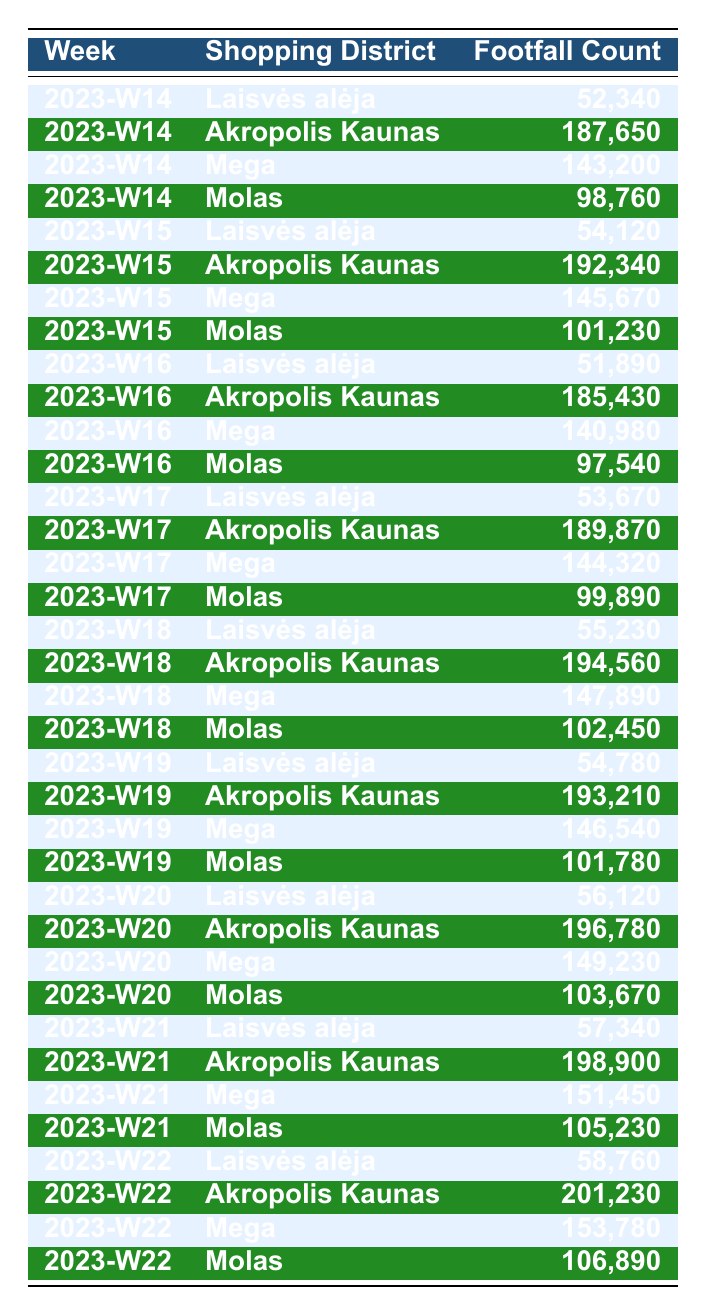What is the footfall count for Akropolis Kaunas in week 2023-W20? In the table under the "Akropolis Kaunas" row for the week "2023-W20," the footfall count is listed as 196,780.
Answer: 196,780 Which shopping district had the highest footfall in week 2023-W18? The table indicates that the footfall count for Akropolis Kaunas in week 2023-W18 is 194,560, which is higher than the other districts' counts listed for that week.
Answer: Akropolis Kaunas What was the average footfall count for Laisvės alėja over the six weeks? To find the average for Laisvės alėja, we sum the footfall counts over the six weeks: (52,340 + 54,120 + 51,890 + 53,670 + 55,230 + 57,340) = 324,590. Then, we divide by 6, giving us an average of 54,098.33.
Answer: 54,098 Did footfall in the Mega district increase every week? By examining the footfall counts for Mega across the weeks, we see that it does not increase every week. For example, it was 143,200 in week 2023-W14 but decreased to 140,980 in week 2023-W16.
Answer: No Which district had the most stable footfall count over the weeks? To determine stability, we look at the variance in footfall counts for each district. Comparing them, Laisvės alėja has the smallest range (54,120 to 58,760), suggesting it had the most stable footfall.
Answer: Laisvės alėja What is the total footfall count for all districts combined in week 2023-W15? We sum the footfall counts from all districts for 2023-W15: (54,120 + 192,340 + 145,670 + 101,230) = 493,360.
Answer: 493,360 Was there an increase in footfall count for Molas from week 2023-W14 to week 2023-W22? Comparing the footfall counts, Molas had 98,760 in week 2023-W14 and 106,890 in week 2023-W22, showing an increase.
Answer: Yes How much more footfall did Akropolis Kaunas receive than Mega in the week with the highest difference? In week 2023-W22, Akropolis Kaunas had a count of 201,230 and Mega had 153,780. The difference is 201,230 - 153,780 = 47,450, which is the highest difference across the weeks.
Answer: 47,450 Which shopping district consistently had the highest footfall each week? By reviewing the footfall counts for each week, it is clear that Akropolis Kaunas consistently holds the highest footfall count compared to the other districts in every week listed.
Answer: Akropolis Kaunas 